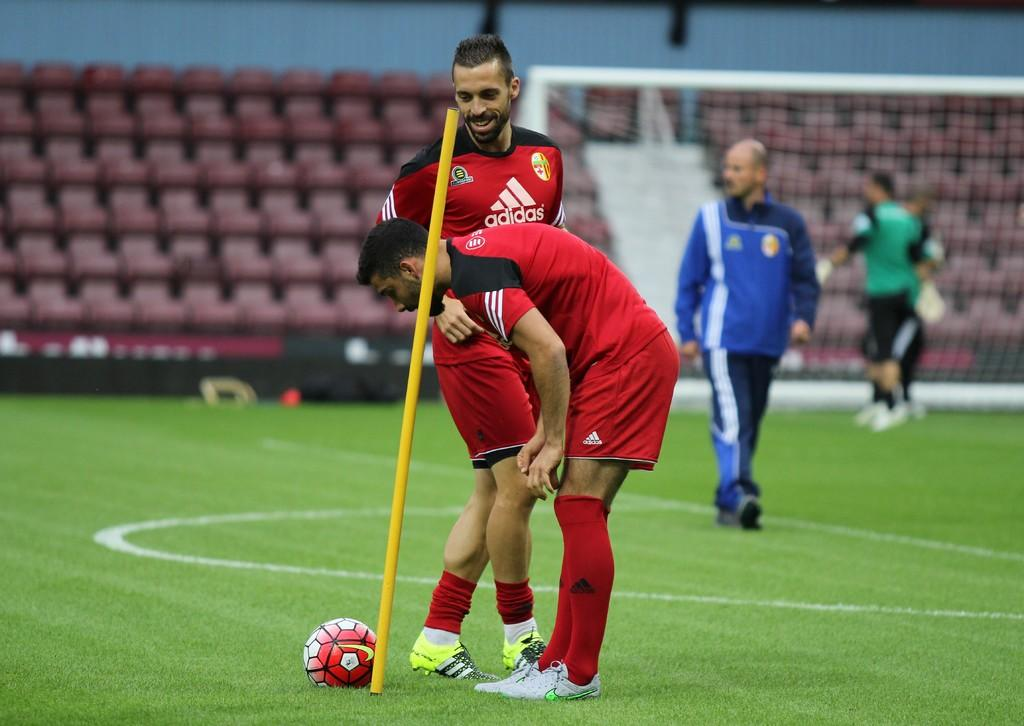<image>
Create a compact narrative representing the image presented. Male soccer players wearing red adidas jerseys and shorts. 